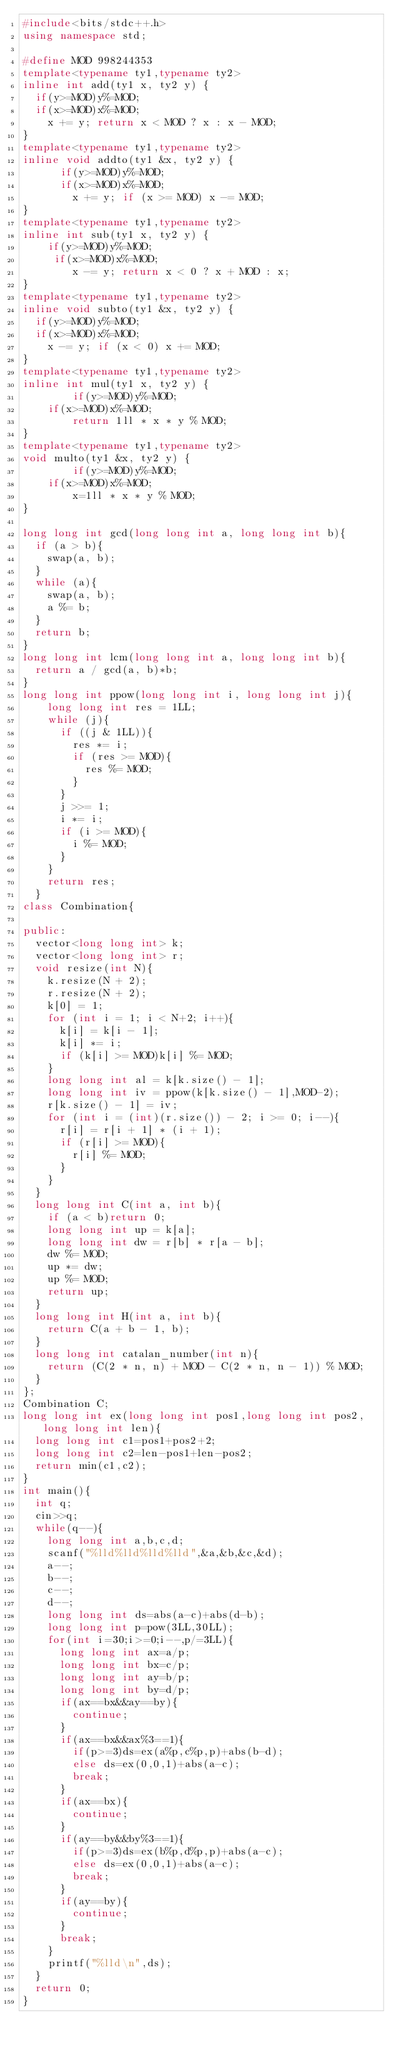Convert code to text. <code><loc_0><loc_0><loc_500><loc_500><_C++_>#include<bits/stdc++.h>
using namespace std;
 
#define MOD 998244353
template<typename ty1,typename ty2>
inline int add(ty1 x, ty2 y) {
	if(y>=MOD)y%=MOD;
	if(x>=MOD)x%=MOD;
    x += y; return x < MOD ? x : x - MOD;
}
template<typename ty1,typename ty2>
inline void addto(ty1 &x, ty2 y) {
		  if(y>=MOD)y%=MOD;
		  if(x>=MOD)x%=MOD;
	      x += y; if (x >= MOD) x -= MOD;
}
template<typename ty1,typename ty2>
inline int sub(ty1 x, ty2 y) {
		if(y>=MOD)y%=MOD;
		 if(x>=MOD)x%=MOD;
        x -= y; return x < 0 ? x + MOD : x;
}
template<typename ty1,typename ty2>
inline void subto(ty1 &x, ty2 y) {
	if(y>=MOD)y%=MOD;
	if(x>=MOD)x%=MOD;
    x -= y; if (x < 0) x += MOD;
}
template<typename ty1,typename ty2>
inline int mul(ty1 x, ty2 y) {
        if(y>=MOD)y%=MOD;
		if(x>=MOD)x%=MOD;
        return 1ll * x * y % MOD;
}
template<typename ty1,typename ty2>
void multo(ty1 &x, ty2 y) {
        if(y>=MOD)y%=MOD;
		if(x>=MOD)x%=MOD;
        x=1ll * x * y % MOD;
}
  
long long int gcd(long long int a, long long int b){
	if (a > b){
		swap(a, b);
	}
	while (a){
		swap(a, b);
		a %= b;
	}
	return b;
}
long long int lcm(long long int a, long long int b){
	return a / gcd(a, b)*b;
}
long long int ppow(long long int i, long long int j){
		long long int res = 1LL;
		while (j){
			if ((j & 1LL)){
				res *= i;
				if (res >= MOD){
					res %= MOD;
				}
			}
			j >>= 1;
			i *= i;
			if (i >= MOD){
				i %= MOD;
			}
		}
		return res;
	}
class Combination{
	
public:
	vector<long long int> k;
	vector<long long int> r;
	void resize(int N){
		k.resize(N + 2);
		r.resize(N + 2);
		k[0] = 1;
		for (int i = 1; i < N+2; i++){
			k[i] = k[i - 1];
			k[i] *= i;
			if (k[i] >= MOD)k[i] %= MOD;
		}
		long long int al = k[k.size() - 1];
		long long int iv = ppow(k[k.size() - 1],MOD-2);
		r[k.size() - 1] = iv;
		for (int i = (int)(r.size()) - 2; i >= 0; i--){
			r[i] = r[i + 1] * (i + 1);
			if (r[i] >= MOD){
				r[i] %= MOD;
			}
		}
	}
	long long int C(int a, int b){
		if (a < b)return 0;
		long long int up = k[a];
		long long int dw = r[b] * r[a - b];
		dw %= MOD;
		up *= dw;
		up %= MOD;
		return up;
	}
	long long int H(int a, int b){
		return C(a + b - 1, b);
	}
	long long int catalan_number(int n){
		return (C(2 * n, n) + MOD - C(2 * n, n - 1)) % MOD;
	}
};
Combination C;
long long int ex(long long int pos1,long long int pos2,long long int len){
	long long int c1=pos1+pos2+2;
	long long int c2=len-pos1+len-pos2;
	return min(c1,c2);
}
int main(){
	int q;
	cin>>q;
	while(q--){
		long long int a,b,c,d;
		scanf("%lld%lld%lld%lld",&a,&b,&c,&d);
		a--;
		b--;
		c--;
		d--;
		long long int ds=abs(a-c)+abs(d-b);
		long long int p=pow(3LL,30LL);
		for(int i=30;i>=0;i--,p/=3LL){
			long long int ax=a/p;
			long long int bx=c/p;
			long long int ay=b/p;
			long long int by=d/p;
			if(ax==bx&&ay==by){
				continue;
			}
			if(ax==bx&&ax%3==1){
				if(p>=3)ds=ex(a%p,c%p,p)+abs(b-d);
				else ds=ex(0,0,1)+abs(a-c);
				break;
			}
			if(ax==bx){
				continue;
			}
			if(ay==by&&by%3==1){
				if(p>=3)ds=ex(b%p,d%p,p)+abs(a-c);
				else ds=ex(0,0,1)+abs(a-c);
				break;
			}
			if(ay==by){
				continue;
			}
			break;
		}
		printf("%lld\n",ds);
	}
	return 0;
}
</code> 